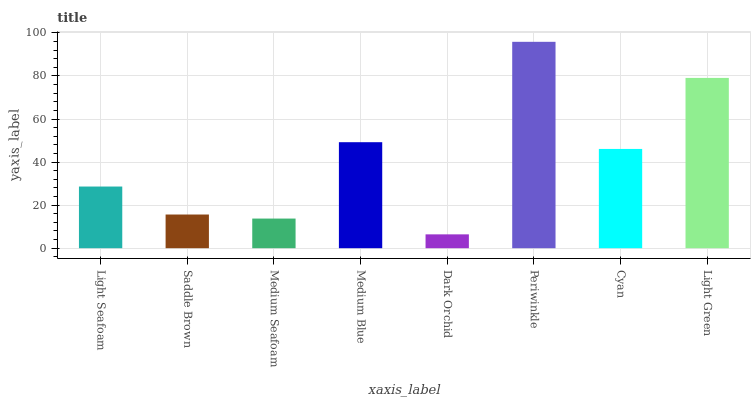Is Periwinkle the maximum?
Answer yes or no. Yes. Is Saddle Brown the minimum?
Answer yes or no. No. Is Saddle Brown the maximum?
Answer yes or no. No. Is Light Seafoam greater than Saddle Brown?
Answer yes or no. Yes. Is Saddle Brown less than Light Seafoam?
Answer yes or no. Yes. Is Saddle Brown greater than Light Seafoam?
Answer yes or no. No. Is Light Seafoam less than Saddle Brown?
Answer yes or no. No. Is Cyan the high median?
Answer yes or no. Yes. Is Light Seafoam the low median?
Answer yes or no. Yes. Is Saddle Brown the high median?
Answer yes or no. No. Is Medium Blue the low median?
Answer yes or no. No. 